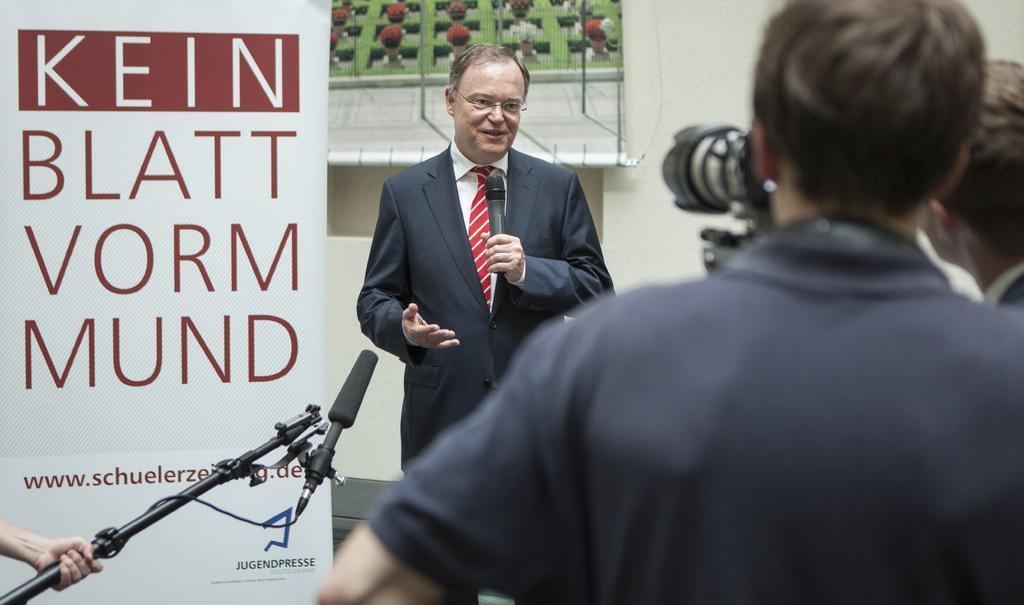Describe this image in one or two sentences. In this picture we can see man wore spectacle,blazer, tie holding mic in his hand and talking and in front of him there is mic stand and two persons, camera and in background we can see banner, wall. 